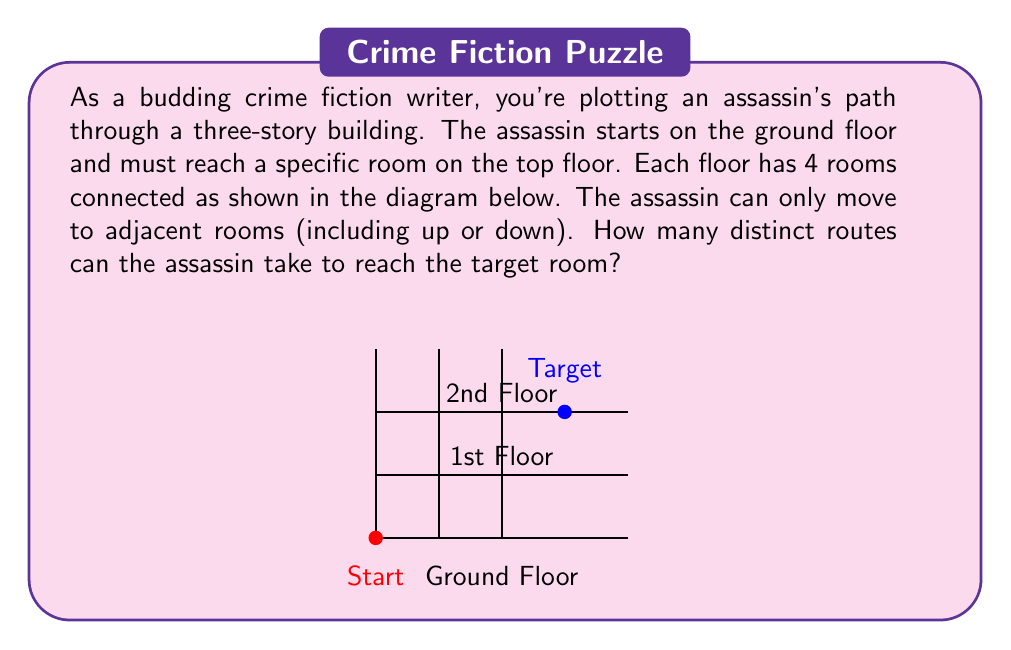Provide a solution to this math problem. Let's approach this step-by-step:

1) First, we need to recognize that this is a path-counting problem. We can use the multiplication principle of counting.

2) Let's break down the path into segments:
   - Ground floor to 1st floor
   - 1st floor to 2nd floor
   - On the 2nd floor to the target room

3) For each segment:
   - To move from one floor to the next, the assassin has 4 choices (one for each room).
   - On the 2nd floor, the assassin needs to reach the rightmost room. The number of ways to do this depends on which room they entered from the 1st floor.

4) Let's count the paths for each possible entry point on the 2nd floor:
   - If entering the leftmost room: 3 ways to reach the target
   - If entering the second room: 2 ways
   - If entering the third room: 1 way
   - If entering the rightmost room: Already at the target

5) Now, we can apply the multiplication principle:
   $$\text{Total paths} = 4 \times 4 \times (3 + 2 + 1 + 1)$$

6) Simplifying:
   $$\text{Total paths} = 4 \times 4 \times 7 = 16 \times 7 = 112$$

Therefore, there are 112 distinct routes the assassin can take.
Answer: 112 routes 